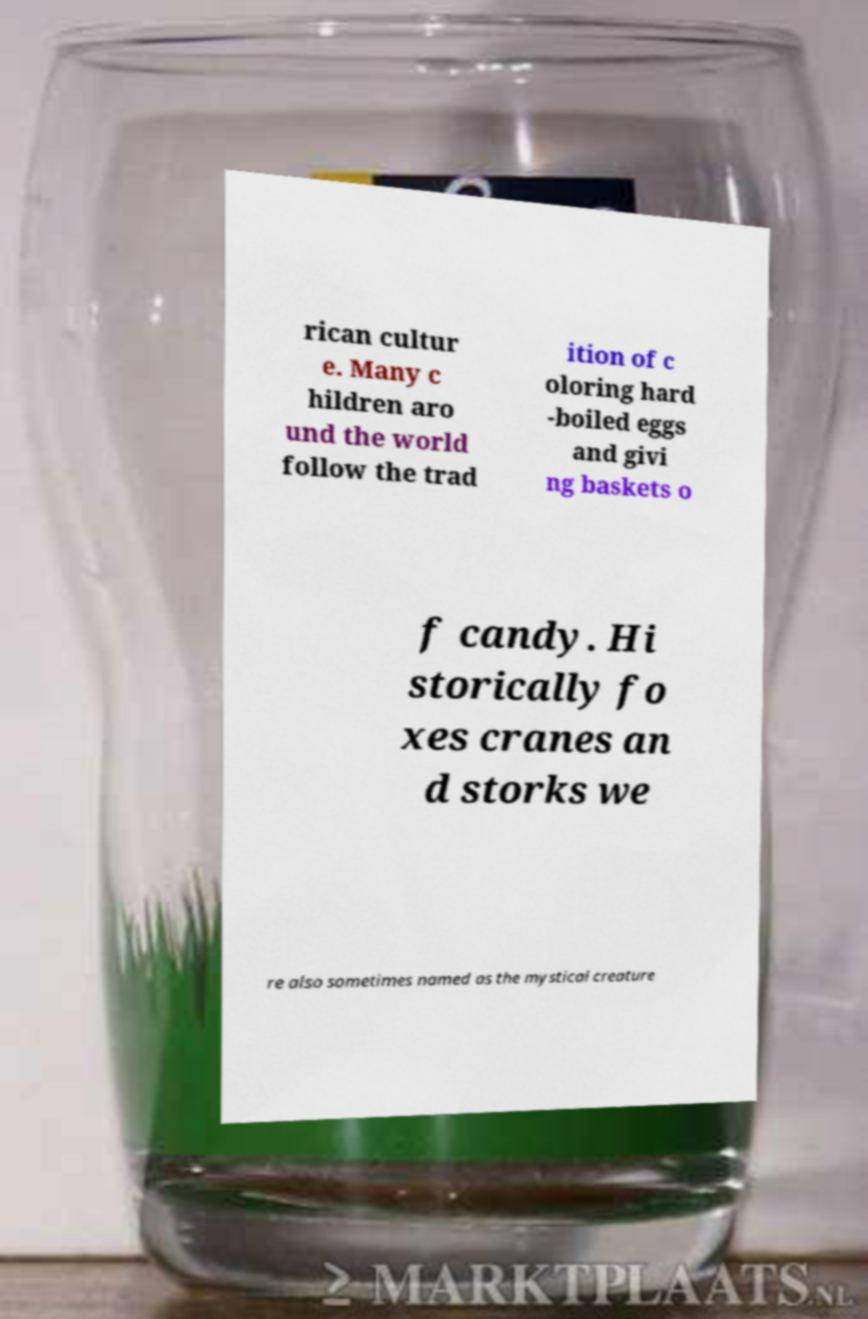Could you assist in decoding the text presented in this image and type it out clearly? rican cultur e. Many c hildren aro und the world follow the trad ition of c oloring hard -boiled eggs and givi ng baskets o f candy. Hi storically fo xes cranes an d storks we re also sometimes named as the mystical creature 